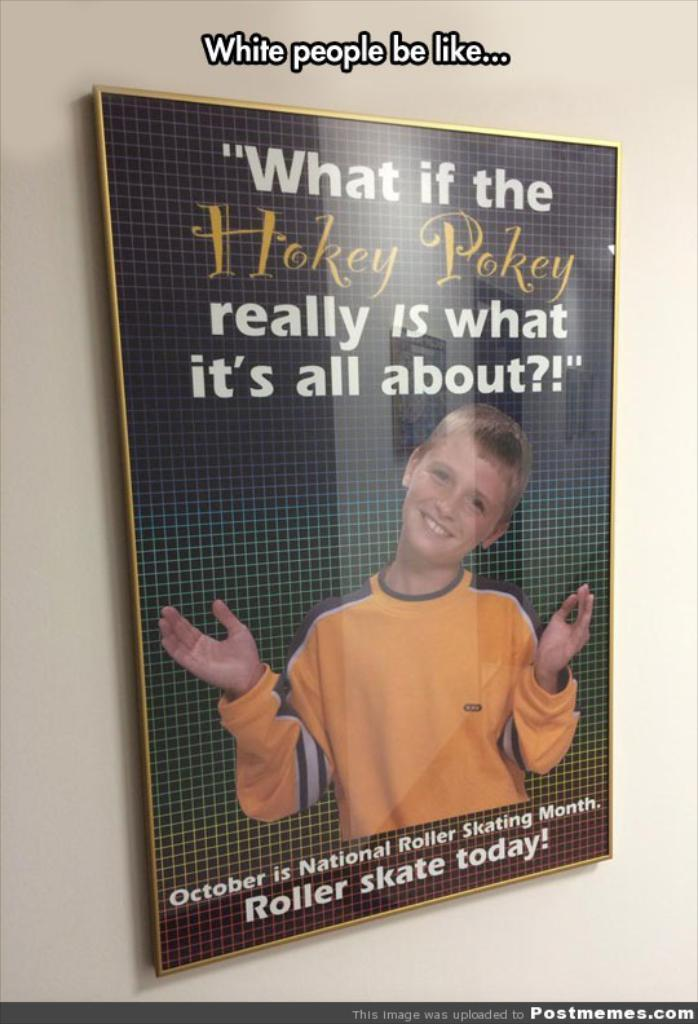<image>
Describe the image concisely. a book that has Hokey Pokey on it 